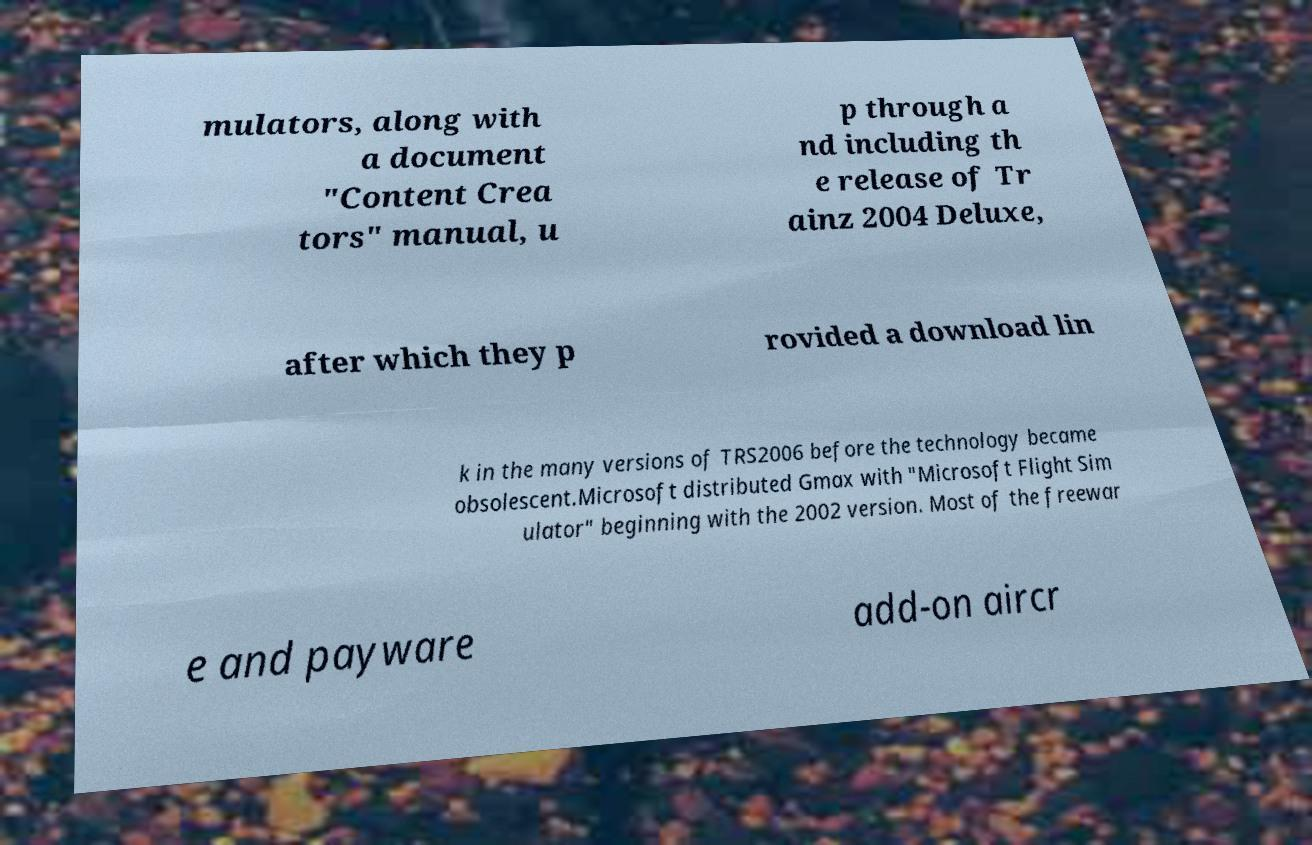Please identify and transcribe the text found in this image. mulators, along with a document "Content Crea tors" manual, u p through a nd including th e release of Tr ainz 2004 Deluxe, after which they p rovided a download lin k in the many versions of TRS2006 before the technology became obsolescent.Microsoft distributed Gmax with "Microsoft Flight Sim ulator" beginning with the 2002 version. Most of the freewar e and payware add-on aircr 